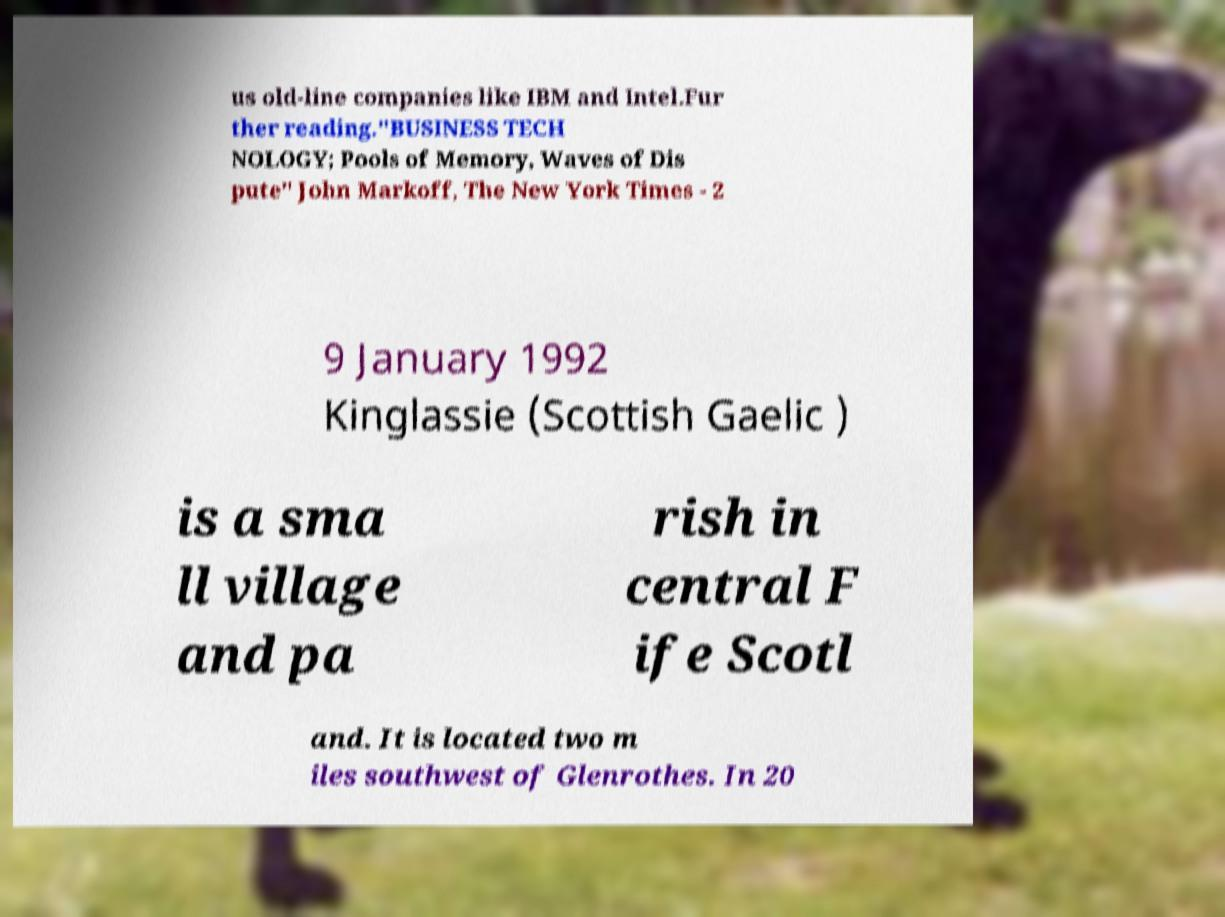Could you assist in decoding the text presented in this image and type it out clearly? us old-line companies like IBM and Intel.Fur ther reading."BUSINESS TECH NOLOGY; Pools of Memory, Waves of Dis pute" John Markoff, The New York Times - 2 9 January 1992 Kinglassie (Scottish Gaelic ) is a sma ll village and pa rish in central F ife Scotl and. It is located two m iles southwest of Glenrothes. In 20 